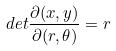Convert formula to latex. <formula><loc_0><loc_0><loc_500><loc_500>d e t \frac { \partial ( x , y ) } { \partial ( r , \theta ) } = r</formula> 